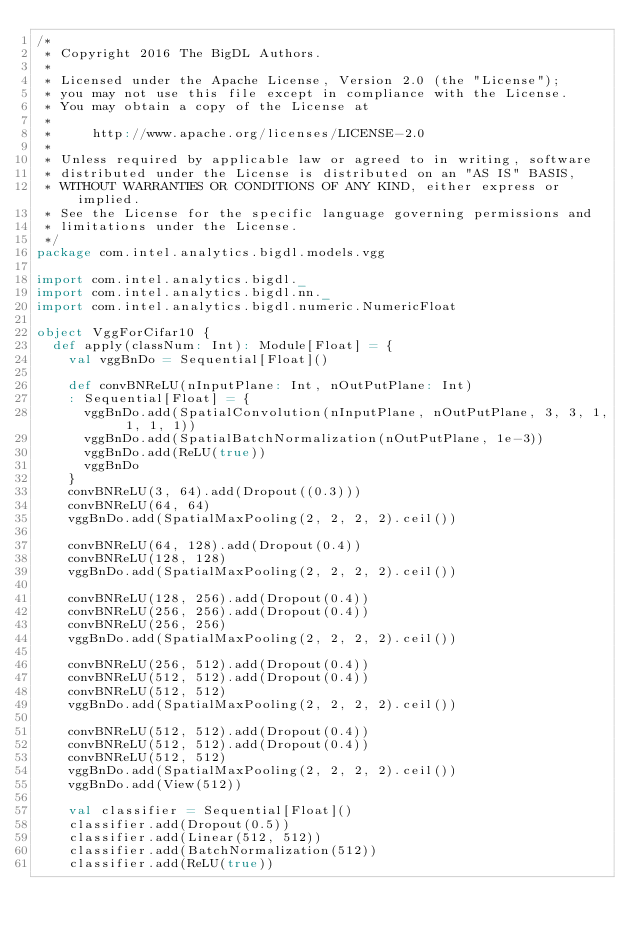<code> <loc_0><loc_0><loc_500><loc_500><_Scala_>/*
 * Copyright 2016 The BigDL Authors.
 *
 * Licensed under the Apache License, Version 2.0 (the "License");
 * you may not use this file except in compliance with the License.
 * You may obtain a copy of the License at
 *
 *     http://www.apache.org/licenses/LICENSE-2.0
 *
 * Unless required by applicable law or agreed to in writing, software
 * distributed under the License is distributed on an "AS IS" BASIS,
 * WITHOUT WARRANTIES OR CONDITIONS OF ANY KIND, either express or implied.
 * See the License for the specific language governing permissions and
 * limitations under the License.
 */
package com.intel.analytics.bigdl.models.vgg

import com.intel.analytics.bigdl._
import com.intel.analytics.bigdl.nn._
import com.intel.analytics.bigdl.numeric.NumericFloat

object VggForCifar10 {
  def apply(classNum: Int): Module[Float] = {
    val vggBnDo = Sequential[Float]()

    def convBNReLU(nInputPlane: Int, nOutPutPlane: Int)
    : Sequential[Float] = {
      vggBnDo.add(SpatialConvolution(nInputPlane, nOutPutPlane, 3, 3, 1, 1, 1, 1))
      vggBnDo.add(SpatialBatchNormalization(nOutPutPlane, 1e-3))
      vggBnDo.add(ReLU(true))
      vggBnDo
    }
    convBNReLU(3, 64).add(Dropout((0.3)))
    convBNReLU(64, 64)
    vggBnDo.add(SpatialMaxPooling(2, 2, 2, 2).ceil())

    convBNReLU(64, 128).add(Dropout(0.4))
    convBNReLU(128, 128)
    vggBnDo.add(SpatialMaxPooling(2, 2, 2, 2).ceil())

    convBNReLU(128, 256).add(Dropout(0.4))
    convBNReLU(256, 256).add(Dropout(0.4))
    convBNReLU(256, 256)
    vggBnDo.add(SpatialMaxPooling(2, 2, 2, 2).ceil())

    convBNReLU(256, 512).add(Dropout(0.4))
    convBNReLU(512, 512).add(Dropout(0.4))
    convBNReLU(512, 512)
    vggBnDo.add(SpatialMaxPooling(2, 2, 2, 2).ceil())

    convBNReLU(512, 512).add(Dropout(0.4))
    convBNReLU(512, 512).add(Dropout(0.4))
    convBNReLU(512, 512)
    vggBnDo.add(SpatialMaxPooling(2, 2, 2, 2).ceil())
    vggBnDo.add(View(512))

    val classifier = Sequential[Float]()
    classifier.add(Dropout(0.5))
    classifier.add(Linear(512, 512))
    classifier.add(BatchNormalization(512))
    classifier.add(ReLU(true))</code> 